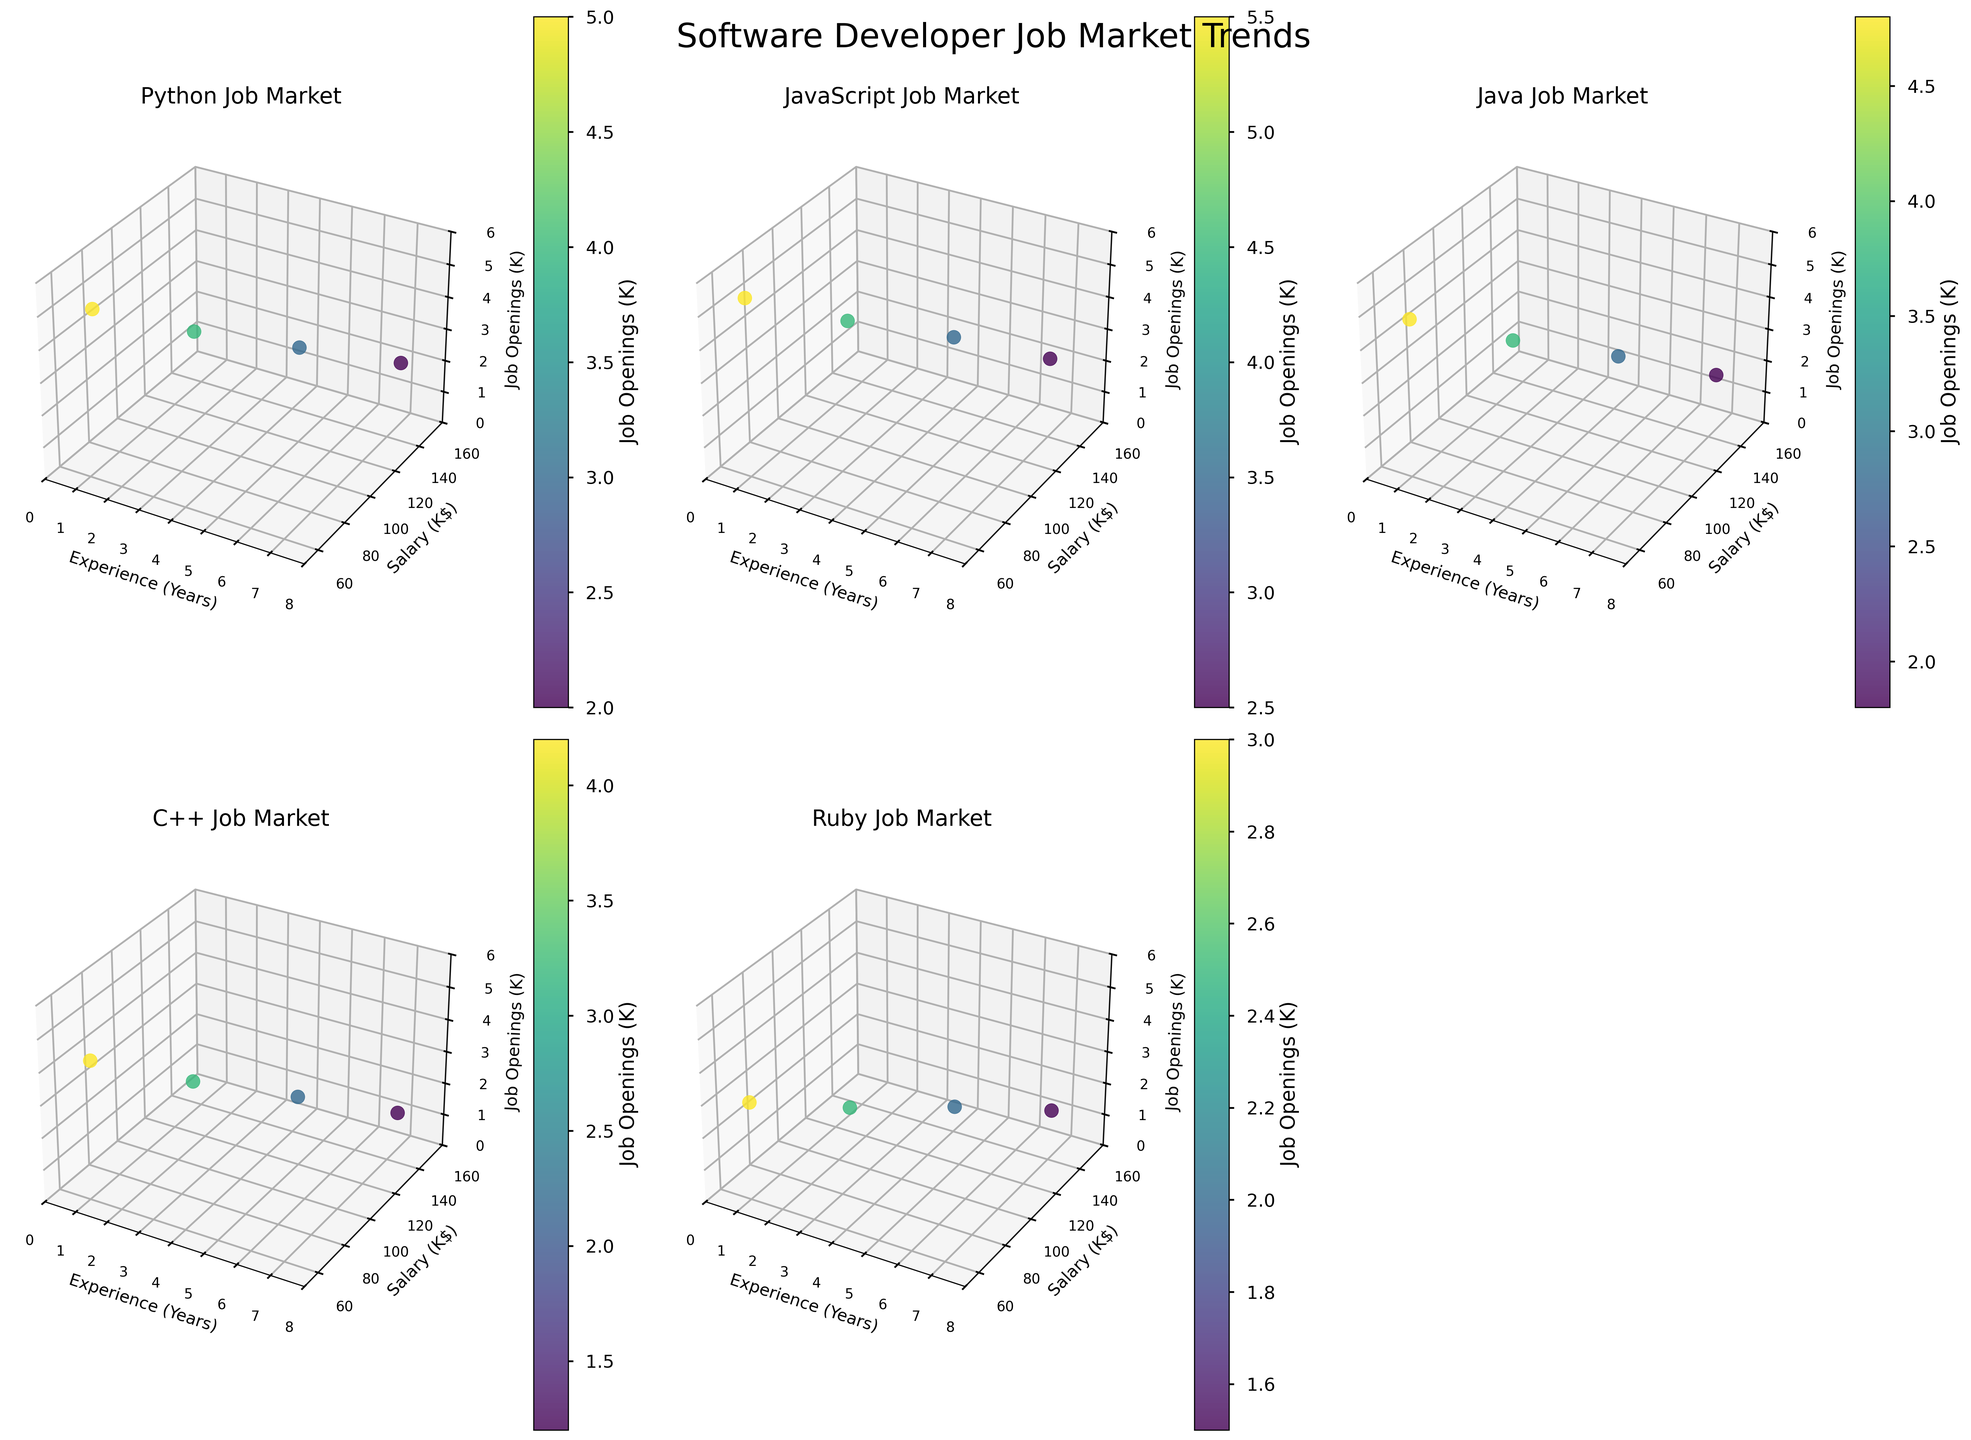What's the highest salary displayed for Python developers? Check the y-axis for the Python subplot and identify the highest y-value, which represents the highest salary.
Answer: 150,000 Which programming language has the most job openings at 1 year of experience? Look at the z-axis values for the dots with an x-value of 1 across all subplots to find the highest z-value. JavaScript has the highest job openings at 1 year of experience.
Answer: JavaScript Which language experiences the greatest increase in salary from 1 to 5 years? Compare the difference in y-values (salaries) between 5-year and 1-year dots for each language subplot. Python shows a salary increase from 65,000 to 120,000 which is the highest increment of 55,000.
Answer: Python How does Ruby's job market trend compare to JavaScript's in terms of job openings at 5 years of experience? Compare the z-values (job openings) for Ruby and JavaScript at the 5-year experience (x-value of 5) in their respective subplots. Ruby has 2,000 job openings while JavaScript has 3,500.
Answer: Ruby has fewer job openings Which programming language shows the smallest decline in job openings as experience increases? Check the z-values from 1 year to 7 years for each language and determine the smallest change. JavaScript, which only decreases from 5,500 to 2,500, shows the smallest decline.
Answer: JavaScript What is the relationship between experience and salary for C++ developers? Look at the pattern of y-values against x-values in the C++ subplot. There is a consistent increase in salary as experience increases from 1 to 7 years.
Answer: Positive correlation How does the salary range of Java developers with 3 years of experience compare to Python developers with the same experience? Compare the y-values for 3 years of experience between Java and Python subplots. Java developers earn 88,000 while Python developers earn 90,000.
Answer: Python developers earn more Which language has the highest average job openings across all experience levels? Average the z-values in each subplot for each language and compare them. JavaScript has the highest average with job openings values of 5,500, 4,500, 3,500, and 2,500.
Answer: JavaScript 